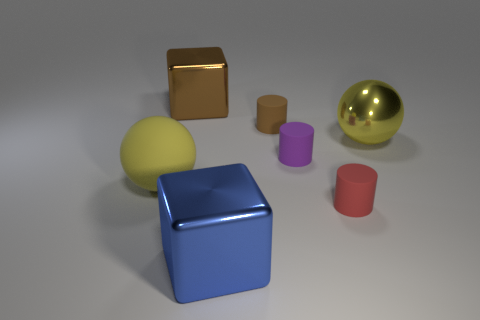Are there fewer cubes behind the large blue block than red metal balls?
Provide a succinct answer. No. Does the big matte sphere have the same color as the big metallic sphere?
Your answer should be compact. Yes. There is a red matte thing that is the same shape as the small purple rubber thing; what size is it?
Offer a terse response. Small. How many large brown blocks are the same material as the large brown object?
Your answer should be compact. 0. Is the material of the brown object that is in front of the brown metal thing the same as the purple cylinder?
Offer a very short reply. Yes. Is the number of big blue cubes behind the big rubber sphere the same as the number of big gray metal blocks?
Your response must be concise. Yes. What size is the red cylinder?
Offer a very short reply. Small. There is a sphere that is the same color as the big rubber object; what material is it?
Your answer should be compact. Metal. How many other matte balls have the same color as the matte sphere?
Your answer should be compact. 0. Do the blue metal thing and the purple matte object have the same size?
Your response must be concise. No. 